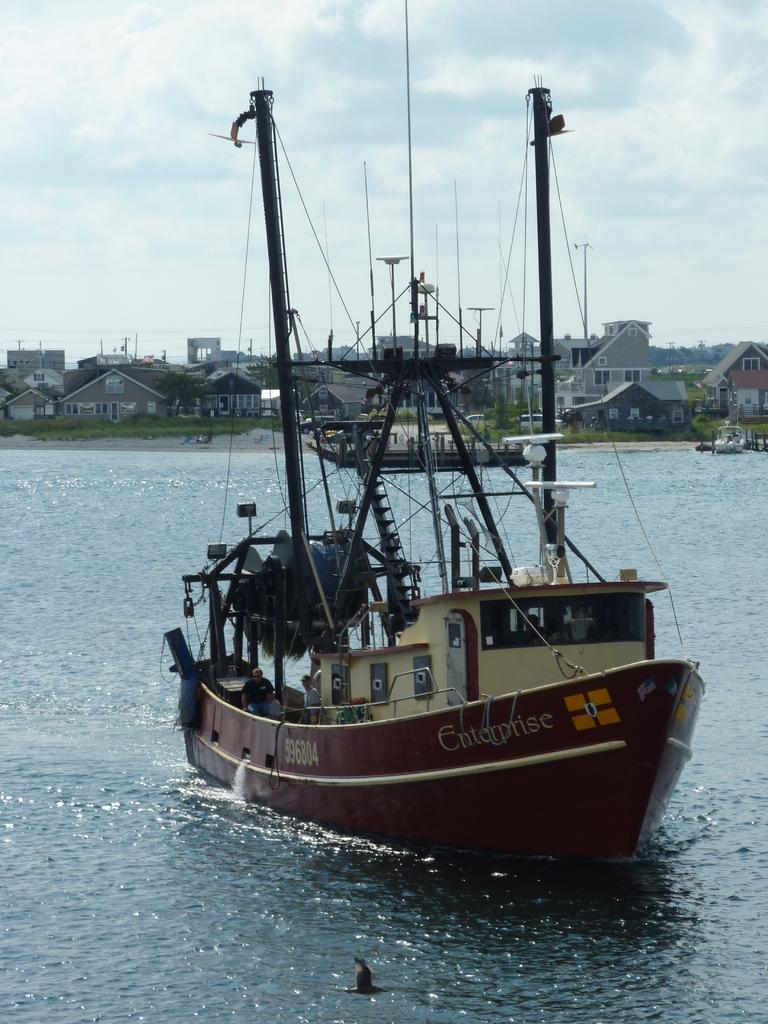What is the main subject of the image? The main subject of the image is a ship. Where is the ship located? The ship is on the water. What objects can be seen in the image related to the ship? There are poles and ropes visible in the image. Are there any people in the image? Yes, there are persons in the image. What can be seen in the background of the image? In the background of the image, there is ground, trees, buildings, and the sky. What is the condition of the sky in the image? The sky is visible in the background of the image, and there are clouds present. How many bikes are parked on the ship in the image? There are no bikes present in the image. What type of fan is being used by the persons in the image? There is no fan visible in the image. 